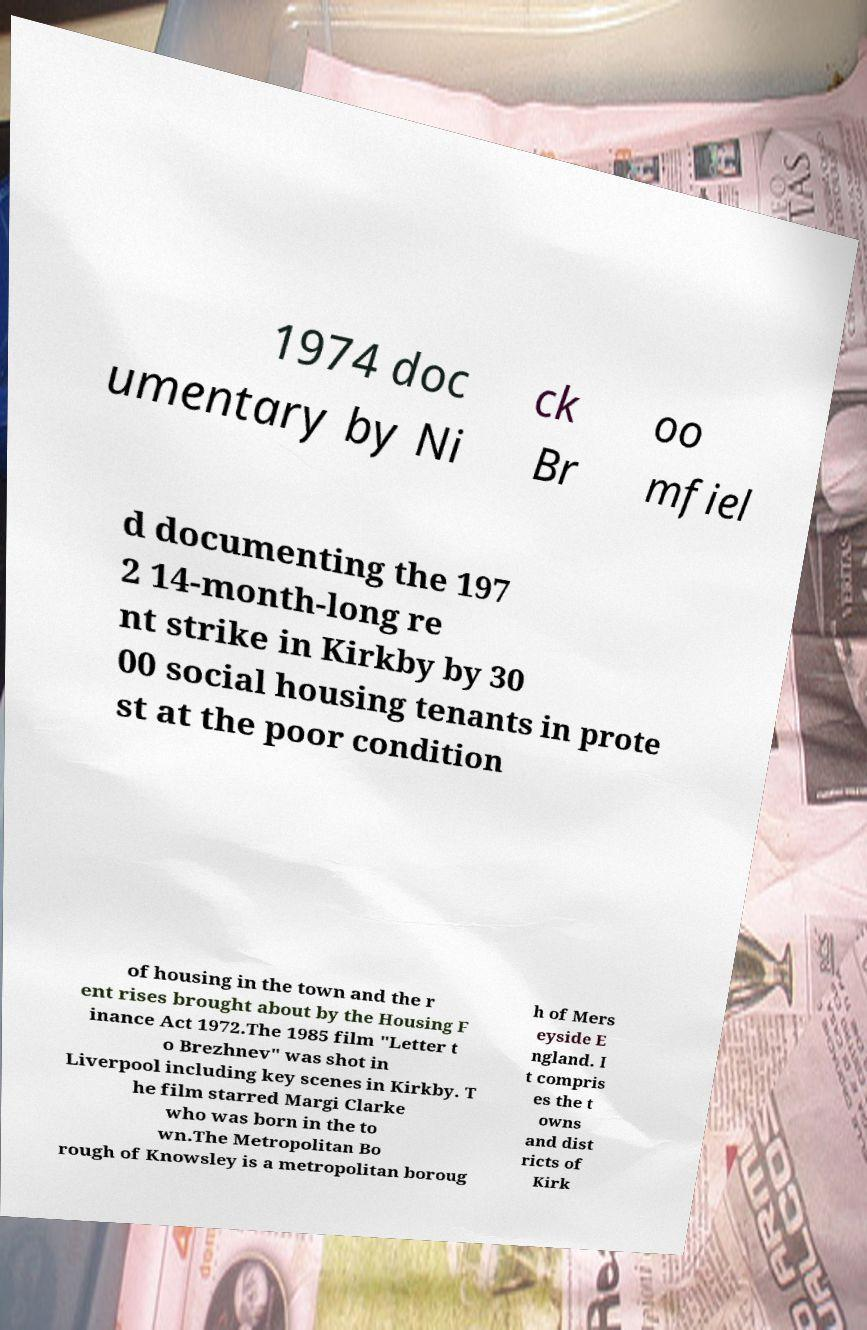Please read and relay the text visible in this image. What does it say? 1974 doc umentary by Ni ck Br oo mfiel d documenting the 197 2 14-month-long re nt strike in Kirkby by 30 00 social housing tenants in prote st at the poor condition of housing in the town and the r ent rises brought about by the Housing F inance Act 1972.The 1985 film "Letter t o Brezhnev" was shot in Liverpool including key scenes in Kirkby. T he film starred Margi Clarke who was born in the to wn.The Metropolitan Bo rough of Knowsley is a metropolitan boroug h of Mers eyside E ngland. I t compris es the t owns and dist ricts of Kirk 